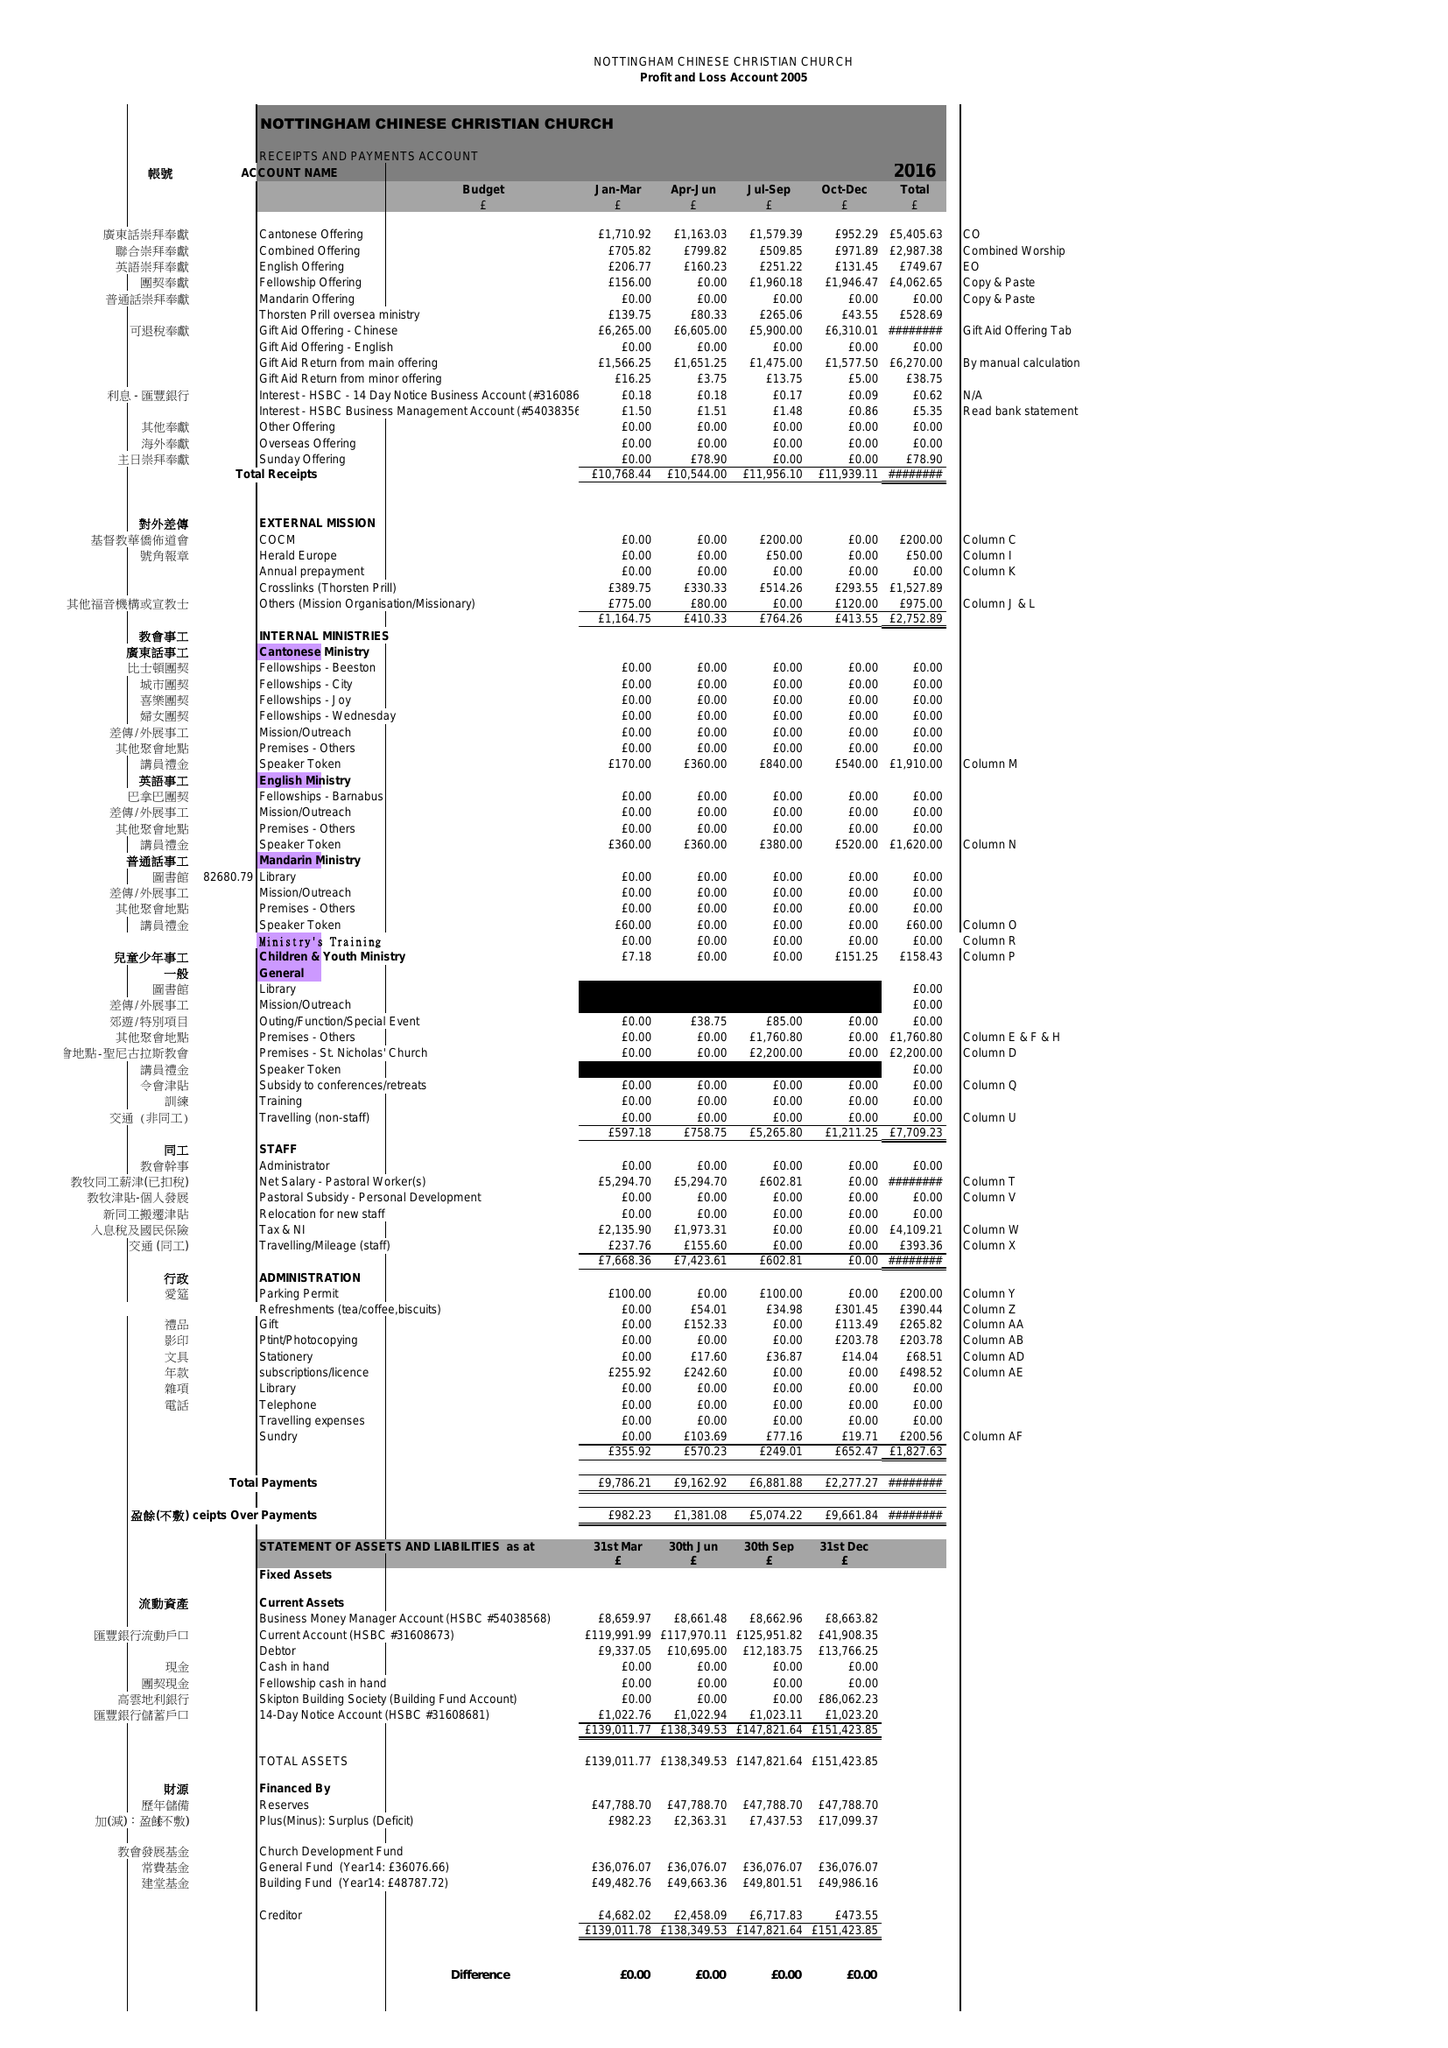What is the value for the charity_number?
Answer the question using a single word or phrase. 1035586 